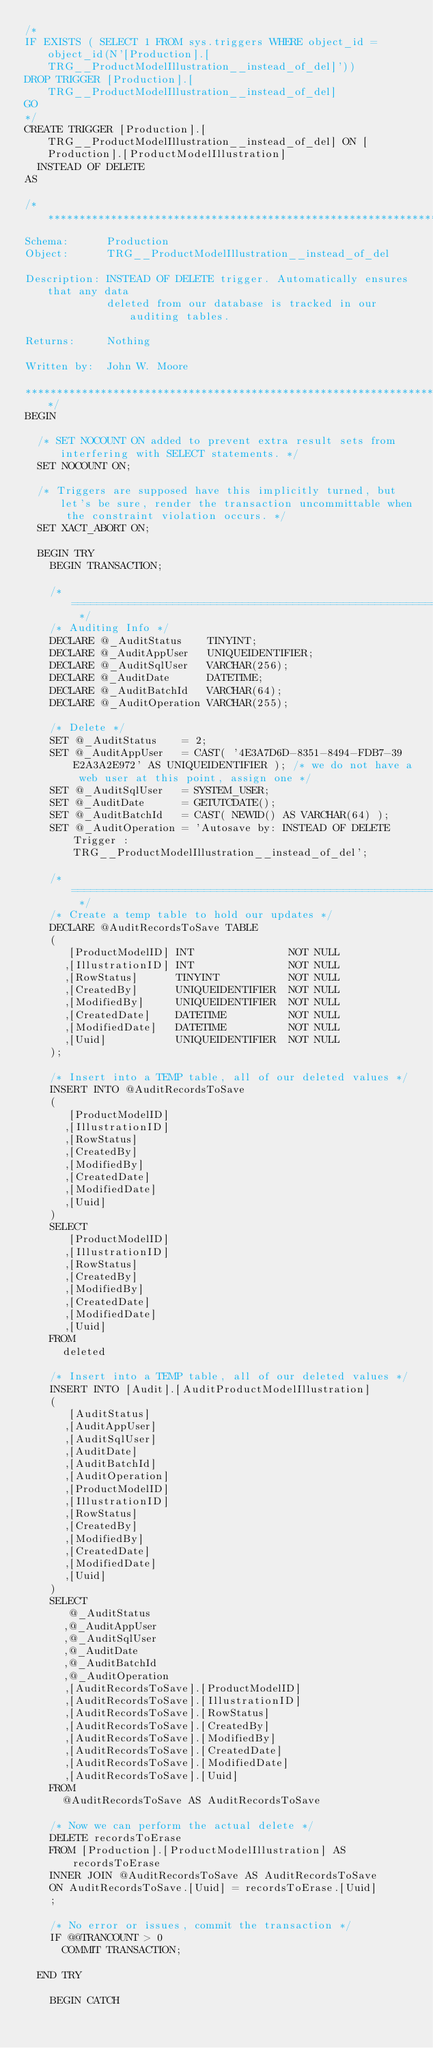<code> <loc_0><loc_0><loc_500><loc_500><_SQL_>/*
IF EXISTS ( SELECT 1 FROM sys.triggers WHERE object_id = object_id(N'[Production].[TRG__ProductModelIllustration__instead_of_del]'))
DROP TRIGGER [Production].[TRG__ProductModelIllustration__instead_of_del]
GO
*/
CREATE TRIGGER [Production].[TRG__ProductModelIllustration__instead_of_del] ON [Production].[ProductModelIllustration]
  INSTEAD OF DELETE
AS

/*******************************************************************************
Schema:      Production
Object:      TRG__ProductModelIllustration__instead_of_del

Description: INSTEAD OF DELETE trigger. Automatically ensures that any data
             deleted from our database is tracked in our auditing tables.
             
Returns:     Nothing

Written by:  John W. Moore

*******************************************************************************/
BEGIN

  /* SET NOCOUNT ON added to prevent extra result sets from interfering with SELECT statements. */
  SET NOCOUNT ON;

  /* Triggers are supposed have this implicitly turned, but let's be sure, render the transaction uncommittable when the constraint violation occurs. */
  SET XACT_ABORT ON;

  BEGIN TRY
    BEGIN TRANSACTION;

    /* ========================================================================= */
    /* Auditing Info */
    DECLARE @_AuditStatus    TINYINT;
    DECLARE @_AuditAppUser   UNIQUEIDENTIFIER;
    DECLARE @_AuditSqlUser   VARCHAR(256);
    DECLARE @_AuditDate      DATETIME;
    DECLARE @_AuditBatchId   VARCHAR(64);
    DECLARE @_AuditOperation VARCHAR(255);

    /* Delete */
    SET @_AuditStatus    = 2; 
    SET @_AuditAppUser   = CAST( '4E3A7D6D-8351-8494-FDB7-39E2A3A2E972' AS UNIQUEIDENTIFIER ); /* we do not have a web user at this point, assign one */
    SET @_AuditSqlUser   = SYSTEM_USER;
    SET @_AuditDate      = GETUTCDATE();
    SET @_AuditBatchId   = CAST( NEWID() AS VARCHAR(64) );
    SET @_AuditOperation = 'Autosave by: INSTEAD OF DELETE Trigger : TRG__ProductModelIllustration__instead_of_del';

    /* ========================================================================= */
    /* Create a temp table to hold our updates */
    DECLARE @AuditRecordsToSave TABLE
    (
       [ProductModelID] INT               NOT NULL
      ,[IllustrationID] INT               NOT NULL
      ,[RowStatus]      TINYINT           NOT NULL
      ,[CreatedBy]      UNIQUEIDENTIFIER  NOT NULL
      ,[ModifiedBy]     UNIQUEIDENTIFIER  NOT NULL
      ,[CreatedDate]    DATETIME          NOT NULL
      ,[ModifiedDate]   DATETIME          NOT NULL
      ,[Uuid]           UNIQUEIDENTIFIER  NOT NULL
    );

    /* Insert into a TEMP table, all of our deleted values */
    INSERT INTO @AuditRecordsToSave
    (
       [ProductModelID]
      ,[IllustrationID]
      ,[RowStatus]
      ,[CreatedBy]
      ,[ModifiedBy]
      ,[CreatedDate]
      ,[ModifiedDate]
      ,[Uuid]
    )
    SELECT
       [ProductModelID]
      ,[IllustrationID]
      ,[RowStatus]
      ,[CreatedBy]
      ,[ModifiedBy]
      ,[CreatedDate]
      ,[ModifiedDate]
      ,[Uuid]
    FROM
      deleted

    /* Insert into a TEMP table, all of our deleted values */
    INSERT INTO [Audit].[AuditProductModelIllustration]
    (
       [AuditStatus]
      ,[AuditAppUser]
      ,[AuditSqlUser]
      ,[AuditDate]
      ,[AuditBatchId]
      ,[AuditOperation]
      ,[ProductModelID]
      ,[IllustrationID]
      ,[RowStatus]
      ,[CreatedBy]
      ,[ModifiedBy]
      ,[CreatedDate]
      ,[ModifiedDate]
      ,[Uuid]
    )
    SELECT
       @_AuditStatus
      ,@_AuditAppUser
      ,@_AuditSqlUser
      ,@_AuditDate
      ,@_AuditBatchId
      ,@_AuditOperation
      ,[AuditRecordsToSave].[ProductModelID]
      ,[AuditRecordsToSave].[IllustrationID]
      ,[AuditRecordsToSave].[RowStatus]
      ,[AuditRecordsToSave].[CreatedBy]
      ,[AuditRecordsToSave].[ModifiedBy]
      ,[AuditRecordsToSave].[CreatedDate]
      ,[AuditRecordsToSave].[ModifiedDate]
      ,[AuditRecordsToSave].[Uuid]
    FROM
      @AuditRecordsToSave AS AuditRecordsToSave

    /* Now we can perform the actual delete */
    DELETE recordsToErase
    FROM [Production].[ProductModelIllustration] AS recordsToErase
    INNER JOIN @AuditRecordsToSave AS AuditRecordsToSave
    ON AuditRecordsToSave.[Uuid] = recordsToErase.[Uuid]
    ;

    /* No error or issues, commit the transaction */
    IF @@TRANCOUNT > 0 
      COMMIT TRANSACTION;

  END TRY

    BEGIN CATCH
</code> 